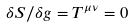Convert formula to latex. <formula><loc_0><loc_0><loc_500><loc_500>\delta S / \delta g = T ^ { \mu \nu } = 0</formula> 